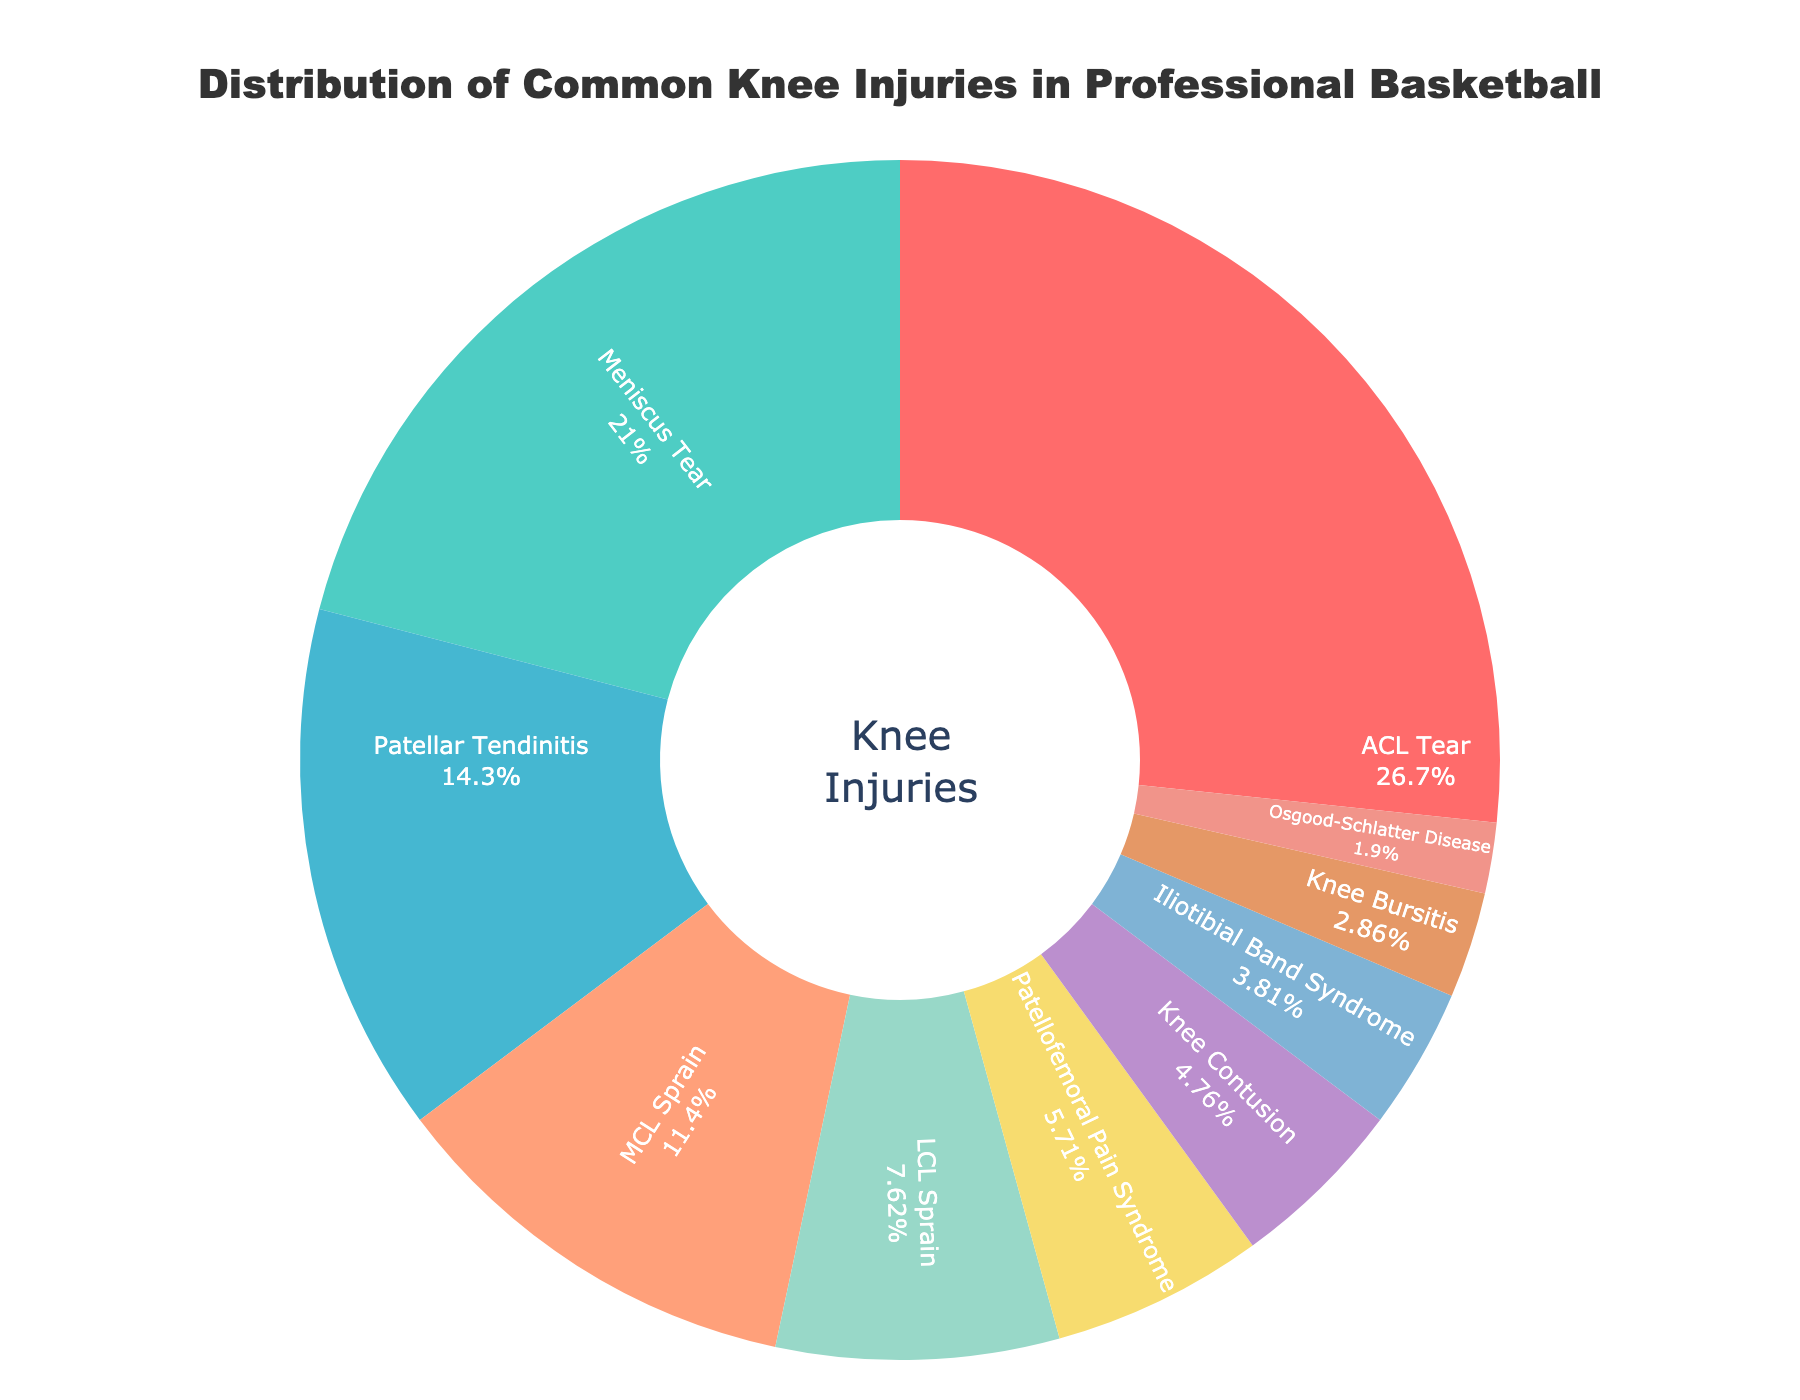What is the most common cause of knee injuries in professional basketball? The pie chart indicates that ACL Tear is the largest segment, representing 28% of knee injuries.
Answer: ACL Tear Which injury has a higher percentage: Meniscus Tear or Patellofemoral Pain Syndrome? Meniscus Tear is 22% while Patellofemoral Pain Syndrome is 6%. Therefore, Meniscus Tear is higher.
Answer: Meniscus Tear What is the combined percentage of ACL Tear and MCL Sprain? ACL Tear is 28% and MCL Sprain is 12%. Adding these together gives 28% + 12% = 40%.
Answer: 40% Which causes of knee injuries combined contribute more than 50% of the total injuries? Adding ACL Tear (28%), Meniscus Tear (22%), and Patellar Tendinitis (15%) results in 28% + 22% + 15% = 65%, which is more than 50%.
Answer: ACL Tear, Meniscus Tear, Patellar Tendinitis If you combine the percentages of LCL Sprain, Iliotibial Band Syndrome, and Osgood-Schlatter Disease, what is the total? The percentages are LCL Sprain (8%), Iliotibial Band Syndrome (4%), and Osgood-Schlatter Disease (2%). Adding them gives 8% + 4% + 2% = 14%.
Answer: 14% How much larger is the percentage for ACL Tear compared to Knee Contusion? ACL Tear is 28% and Knee Contusion is 5%. The difference is 28% - 5% = 23%.
Answer: 23% What is the least common cause of knee injuries and its percentage? The smallest segment in the pie chart is Osgood-Schlatter Disease at 2%.
Answer: Osgood-Schlatter Disease, 2% How many injuries have a percentage greater than 10%? Examining the pie chart, the injuries are ACL Tear (28%), Meniscus Tear (22%), Patellar Tendinitis (15%), and MCL Sprain (12%). This totals to 4 injuries.
Answer: 4 injuries Which has a higher percentage: Knee Bursitis or Iliotibial Band Syndrome? According to the pie chart, Knee Bursitis is 3% and Iliotibial Band Syndrome is 4%. Therefore, Iliotibial Band Syndrome is higher.
Answer: Iliotibial Band Syndrome What is the percentage difference between Patellar Tendinitis and LCL Sprain? Patellar Tendinitis is 15% while LCL Sprain is 8%. The difference is 15% - 8% = 7%.
Answer: 7% 